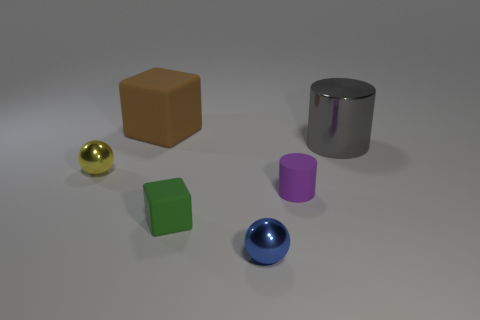How many small yellow spheres are there?
Your response must be concise. 1. How many purple cylinders are the same size as the green rubber thing?
Give a very brief answer. 1. What is the material of the purple thing?
Provide a succinct answer. Rubber. Is there any other thing that is the same size as the brown matte block?
Provide a short and direct response. Yes. There is a object that is in front of the tiny cylinder and to the left of the blue thing; what size is it?
Provide a short and direct response. Small. What shape is the large gray object that is the same material as the small yellow ball?
Offer a very short reply. Cylinder. Are the big brown thing and the tiny sphere on the left side of the green rubber thing made of the same material?
Keep it short and to the point. No. There is a rubber block in front of the yellow metal object; is there a large gray shiny object left of it?
Make the answer very short. No. What material is the other object that is the same shape as the green object?
Make the answer very short. Rubber. There is a tiny rubber thing that is on the right side of the tiny green cube; what number of tiny purple objects are in front of it?
Offer a very short reply. 0. 